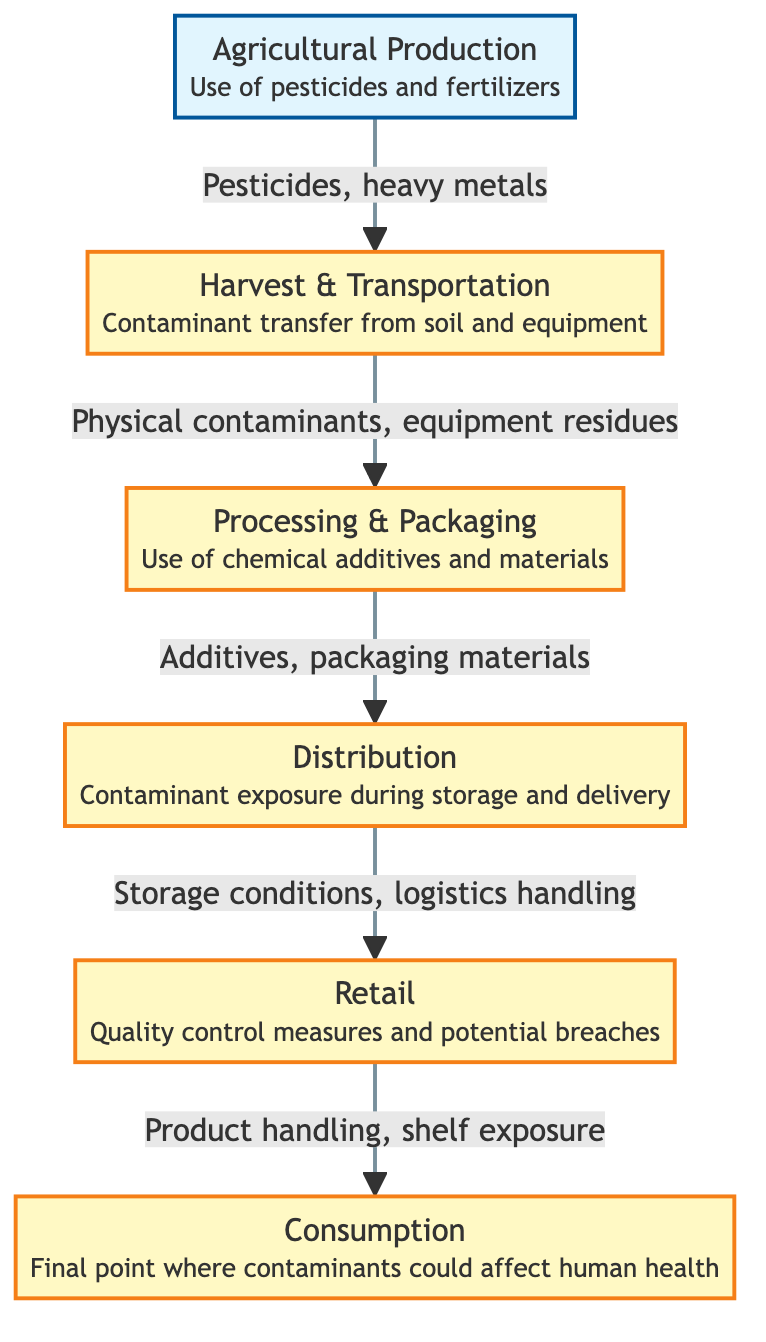What is the first stage of the food chain? The first stage is "Agricultural Production," as indicated by the diagram, which lists it at the beginning of the food chain.
Answer: Agricultural Production How many total stages are present in the diagram? There are six distinct stages in the diagram, listed sequentially from Agricultural Production to Consumption.
Answer: 6 What contaminants are associated with the second stage? The contaminants related to the second stage, "Harvest & Transportation," are "Physical contaminants, equipment residues" listed below the stage.
Answer: Physical contaminants, equipment residues Which stage involves the use of additives? The stage that involves additives is "Processing & Packaging," as it explicitly mentions the use of chemical additives and materials.
Answer: Processing & Packaging What is the final stage of the process flow? The last stage is "Consumption," where the process culminates and human health may be affected by contaminants.
Answer: Consumption How do contaminants transfer from the third stage to the fourth stage? Contaminants transfer from "Processing & Packaging" to "Distribution" through "Additives, packaging materials," as indicated in the arrow description.
Answer: Additives, packaging materials What is the main concern during the retail stage? The primary concern during the retail stage is "Quality control measures and potential breaches," as stated in the description of that stage.
Answer: Quality control measures and potential breaches Which stage connects to the retail stage? The stage that connects directly to the retail stage is "Distribution," indicated by the flow arrow leading to Retail.
Answer: Distribution What type of contaminants are transferred from Agricultural Production to Harvest & Transportation? The type of contaminants transferred from "Agricultural Production" to "Harvest & Transportation" are "Pesticides, heavy metals," as shown in the flow.
Answer: Pesticides, heavy metals 